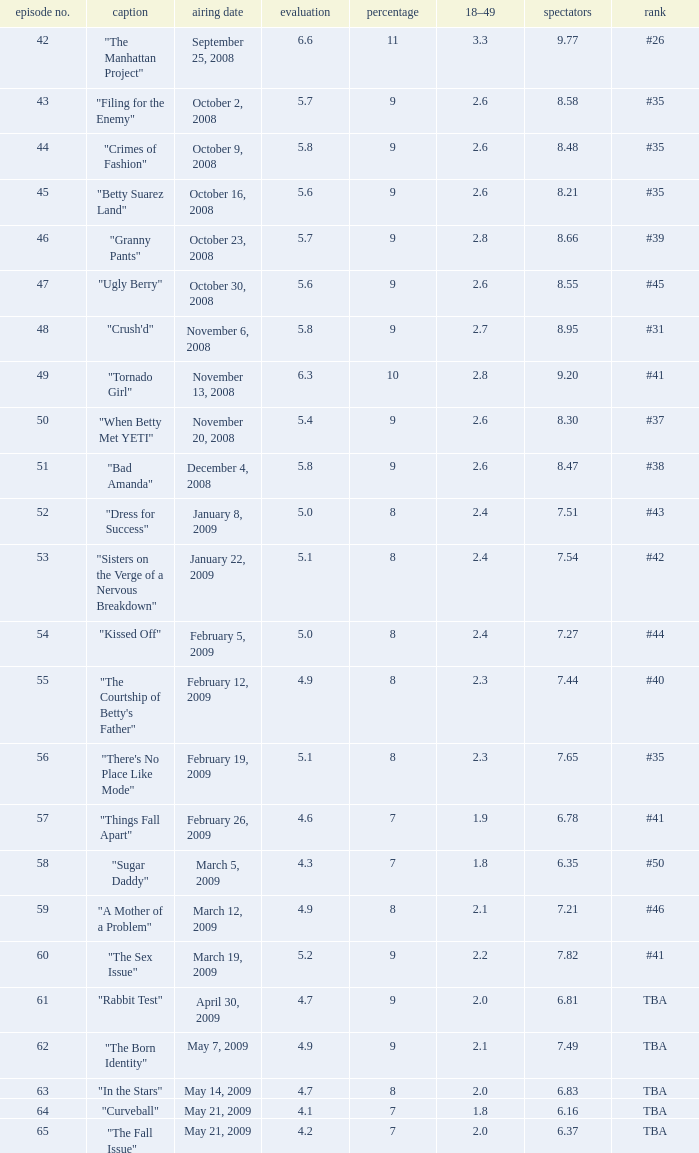What is the average Episode # with a share of 9, and #35 is rank and less than 8.21 viewers? None. 